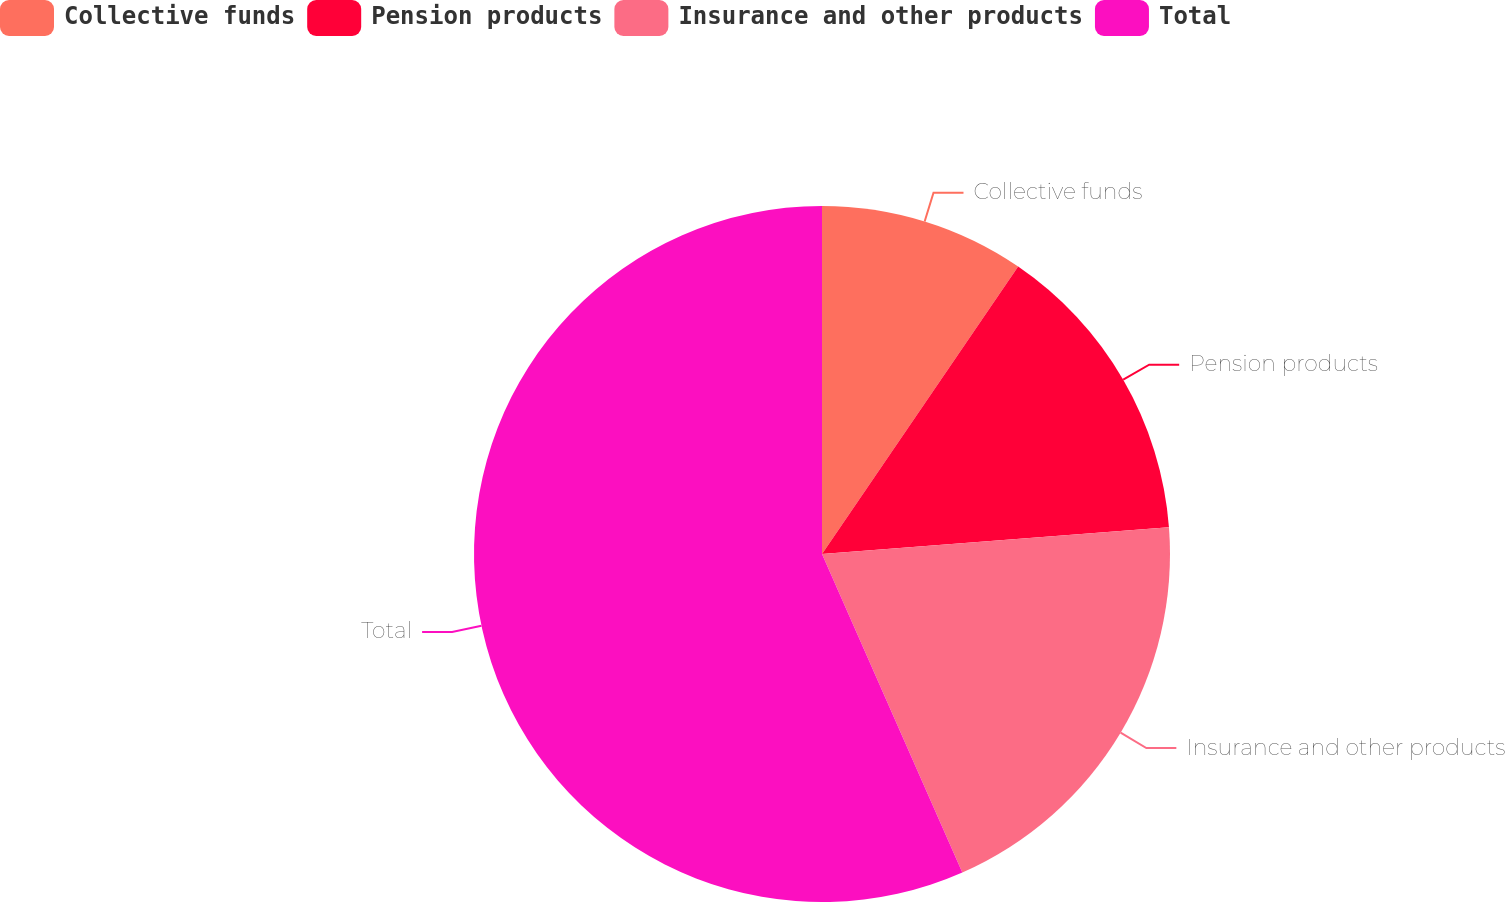Convert chart to OTSL. <chart><loc_0><loc_0><loc_500><loc_500><pie_chart><fcel>Collective funds<fcel>Pension products<fcel>Insurance and other products<fcel>Total<nl><fcel>9.53%<fcel>14.24%<fcel>19.62%<fcel>56.6%<nl></chart> 